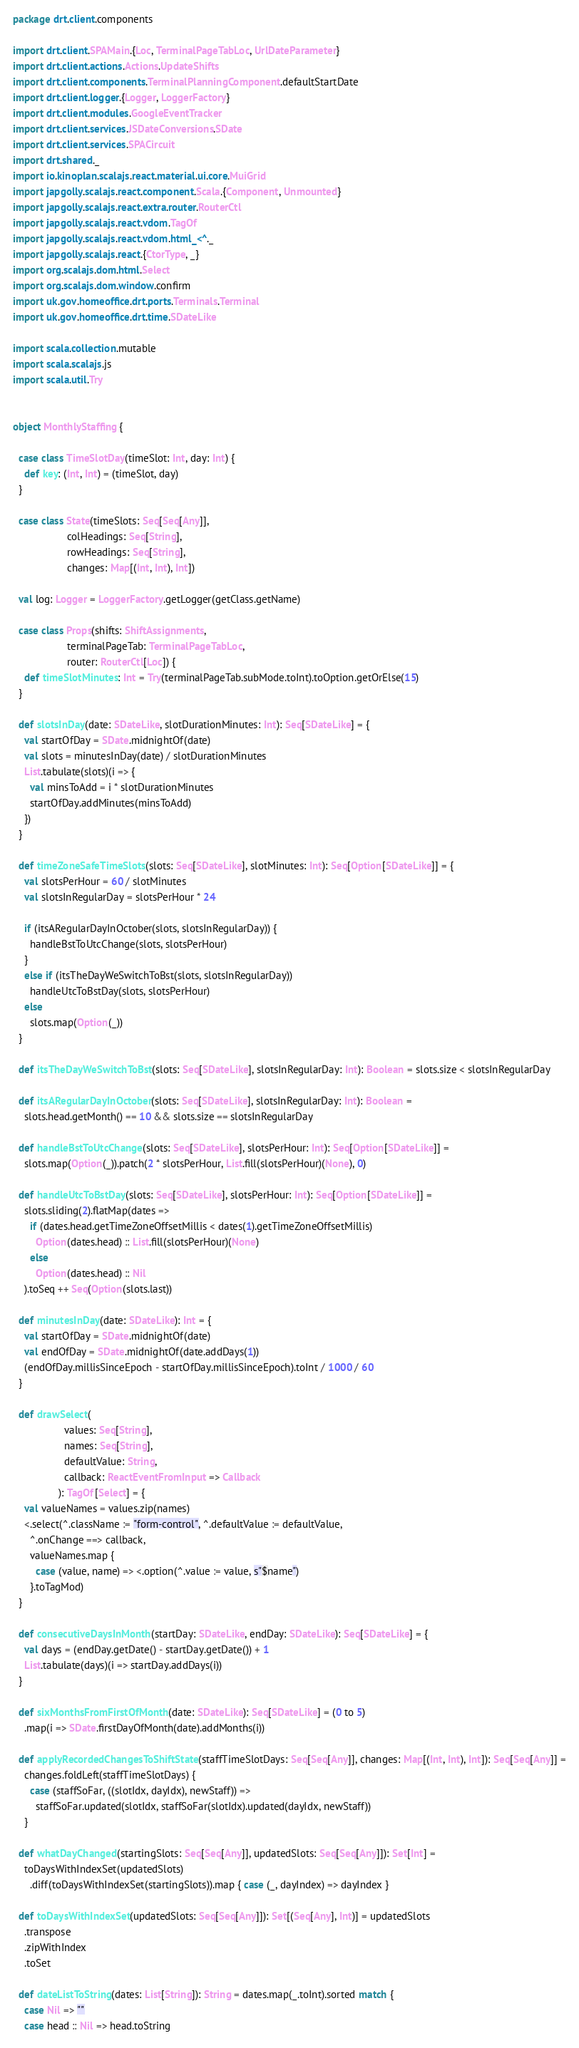Convert code to text. <code><loc_0><loc_0><loc_500><loc_500><_Scala_>package drt.client.components

import drt.client.SPAMain.{Loc, TerminalPageTabLoc, UrlDateParameter}
import drt.client.actions.Actions.UpdateShifts
import drt.client.components.TerminalPlanningComponent.defaultStartDate
import drt.client.logger.{Logger, LoggerFactory}
import drt.client.modules.GoogleEventTracker
import drt.client.services.JSDateConversions.SDate
import drt.client.services.SPACircuit
import drt.shared._
import io.kinoplan.scalajs.react.material.ui.core.MuiGrid
import japgolly.scalajs.react.component.Scala.{Component, Unmounted}
import japgolly.scalajs.react.extra.router.RouterCtl
import japgolly.scalajs.react.vdom.TagOf
import japgolly.scalajs.react.vdom.html_<^._
import japgolly.scalajs.react.{CtorType, _}
import org.scalajs.dom.html.Select
import org.scalajs.dom.window.confirm
import uk.gov.homeoffice.drt.ports.Terminals.Terminal
import uk.gov.homeoffice.drt.time.SDateLike

import scala.collection.mutable
import scala.scalajs.js
import scala.util.Try


object MonthlyStaffing {

  case class TimeSlotDay(timeSlot: Int, day: Int) {
    def key: (Int, Int) = (timeSlot, day)
  }

  case class State(timeSlots: Seq[Seq[Any]],
                   colHeadings: Seq[String],
                   rowHeadings: Seq[String],
                   changes: Map[(Int, Int), Int])

  val log: Logger = LoggerFactory.getLogger(getClass.getName)

  case class Props(shifts: ShiftAssignments,
                   terminalPageTab: TerminalPageTabLoc,
                   router: RouterCtl[Loc]) {
    def timeSlotMinutes: Int = Try(terminalPageTab.subMode.toInt).toOption.getOrElse(15)
  }

  def slotsInDay(date: SDateLike, slotDurationMinutes: Int): Seq[SDateLike] = {
    val startOfDay = SDate.midnightOf(date)
    val slots = minutesInDay(date) / slotDurationMinutes
    List.tabulate(slots)(i => {
      val minsToAdd = i * slotDurationMinutes
      startOfDay.addMinutes(minsToAdd)
    })
  }

  def timeZoneSafeTimeSlots(slots: Seq[SDateLike], slotMinutes: Int): Seq[Option[SDateLike]] = {
    val slotsPerHour = 60 / slotMinutes
    val slotsInRegularDay = slotsPerHour * 24

    if (itsARegularDayInOctober(slots, slotsInRegularDay)) {
      handleBstToUtcChange(slots, slotsPerHour)
    }
    else if (itsTheDayWeSwitchToBst(slots, slotsInRegularDay))
      handleUtcToBstDay(slots, slotsPerHour)
    else
      slots.map(Option(_))
  }

  def itsTheDayWeSwitchToBst(slots: Seq[SDateLike], slotsInRegularDay: Int): Boolean = slots.size < slotsInRegularDay

  def itsARegularDayInOctober(slots: Seq[SDateLike], slotsInRegularDay: Int): Boolean =
    slots.head.getMonth() == 10 && slots.size == slotsInRegularDay

  def handleBstToUtcChange(slots: Seq[SDateLike], slotsPerHour: Int): Seq[Option[SDateLike]] =
    slots.map(Option(_)).patch(2 * slotsPerHour, List.fill(slotsPerHour)(None), 0)

  def handleUtcToBstDay(slots: Seq[SDateLike], slotsPerHour: Int): Seq[Option[SDateLike]] =
    slots.sliding(2).flatMap(dates =>
      if (dates.head.getTimeZoneOffsetMillis < dates(1).getTimeZoneOffsetMillis)
        Option(dates.head) :: List.fill(slotsPerHour)(None)
      else
        Option(dates.head) :: Nil
    ).toSeq ++ Seq(Option(slots.last))

  def minutesInDay(date: SDateLike): Int = {
    val startOfDay = SDate.midnightOf(date)
    val endOfDay = SDate.midnightOf(date.addDays(1))
    (endOfDay.millisSinceEpoch - startOfDay.millisSinceEpoch).toInt / 1000 / 60
  }

  def drawSelect(
                  values: Seq[String],
                  names: Seq[String],
                  defaultValue: String,
                  callback: ReactEventFromInput => Callback
                ): TagOf[Select] = {
    val valueNames = values.zip(names)
    <.select(^.className := "form-control", ^.defaultValue := defaultValue,
      ^.onChange ==> callback,
      valueNames.map {
        case (value, name) => <.option(^.value := value, s"$name")
      }.toTagMod)
  }

  def consecutiveDaysInMonth(startDay: SDateLike, endDay: SDateLike): Seq[SDateLike] = {
    val days = (endDay.getDate() - startDay.getDate()) + 1
    List.tabulate(days)(i => startDay.addDays(i))
  }

  def sixMonthsFromFirstOfMonth(date: SDateLike): Seq[SDateLike] = (0 to 5)
    .map(i => SDate.firstDayOfMonth(date).addMonths(i))

  def applyRecordedChangesToShiftState(staffTimeSlotDays: Seq[Seq[Any]], changes: Map[(Int, Int), Int]): Seq[Seq[Any]] =
    changes.foldLeft(staffTimeSlotDays) {
      case (staffSoFar, ((slotIdx, dayIdx), newStaff)) =>
        staffSoFar.updated(slotIdx, staffSoFar(slotIdx).updated(dayIdx, newStaff))
    }

  def whatDayChanged(startingSlots: Seq[Seq[Any]], updatedSlots: Seq[Seq[Any]]): Set[Int] =
    toDaysWithIndexSet(updatedSlots)
      .diff(toDaysWithIndexSet(startingSlots)).map { case (_, dayIndex) => dayIndex }

  def toDaysWithIndexSet(updatedSlots: Seq[Seq[Any]]): Set[(Seq[Any], Int)] = updatedSlots
    .transpose
    .zipWithIndex
    .toSet

  def dateListToString(dates: List[String]): String = dates.map(_.toInt).sorted match {
    case Nil => ""
    case head :: Nil => head.toString</code> 